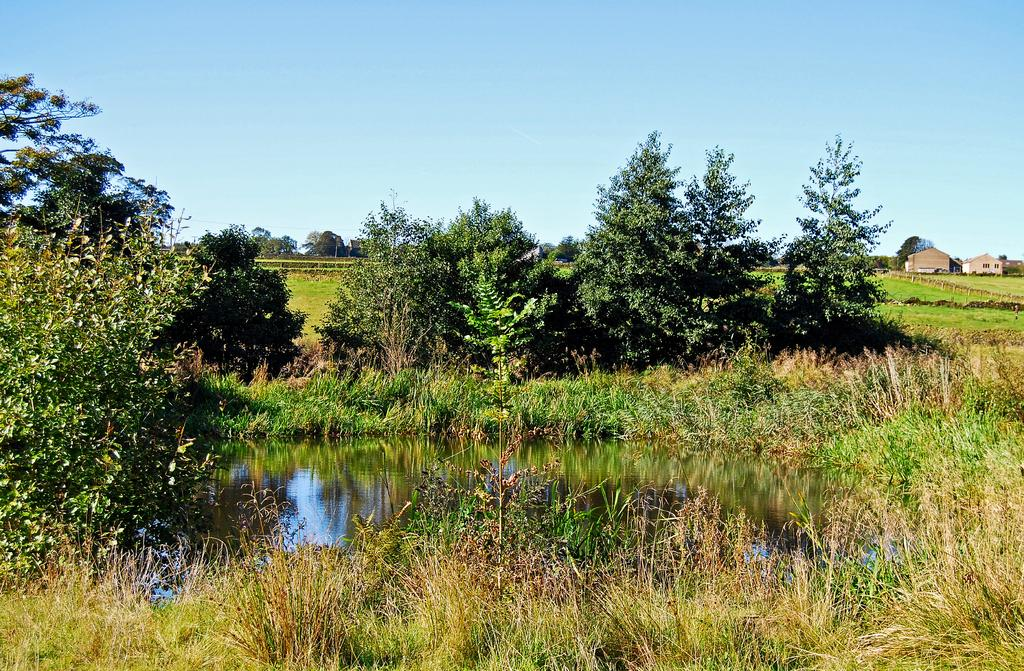What is located in the center of the image? There are trees in the center of the image. What can be seen at the bottom of the image? There is a pond and grass present at the bottom of the image. What structures are on the right side of the image? There are sheds on the right side of the image. What is visible at the top of the image? The sky is visible at the top of the image. Can you tell me how many aunts are sitting by the pond in the image? There are no people, including aunts, present in the image. What color is the sweater worn by the tree in the image? Trees do not wear sweaters, and there are no people or animals in the image. 